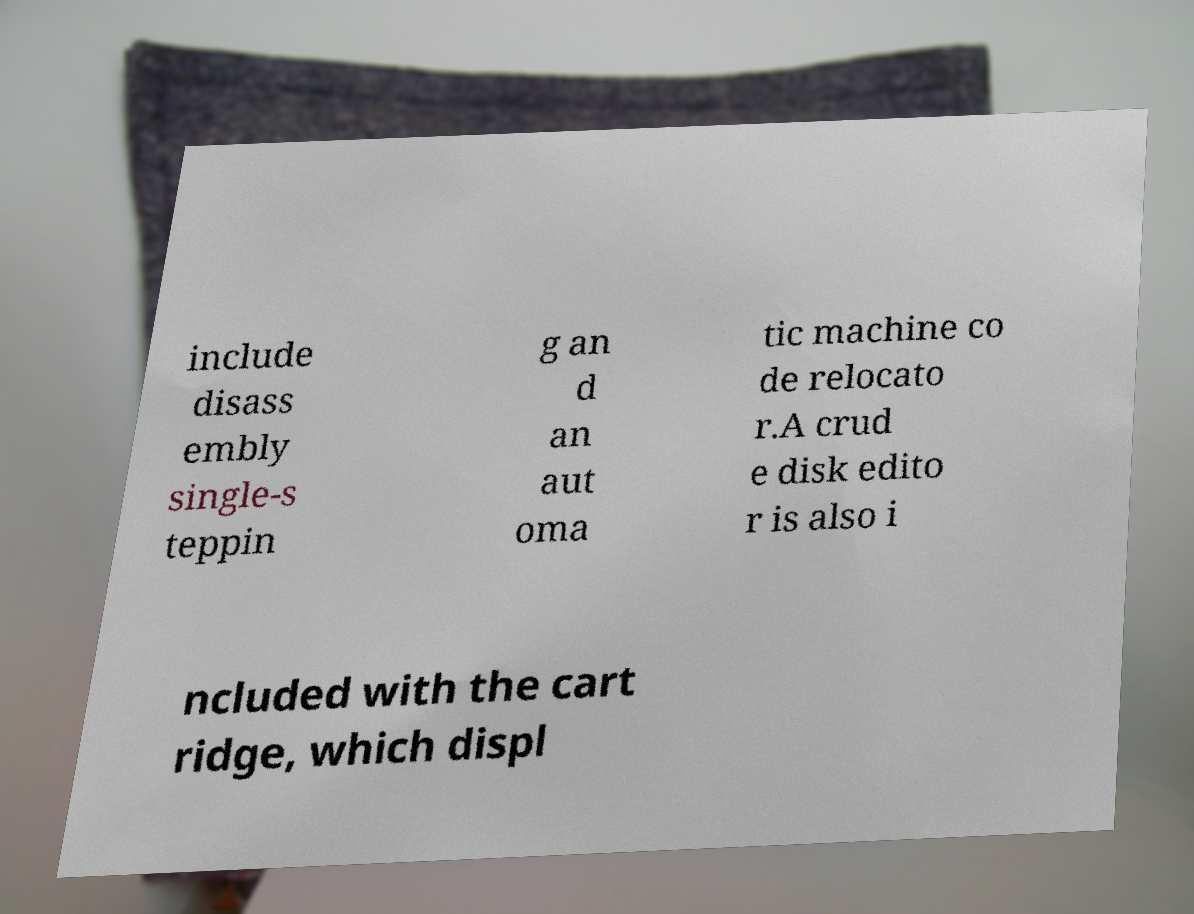For documentation purposes, I need the text within this image transcribed. Could you provide that? include disass embly single-s teppin g an d an aut oma tic machine co de relocato r.A crud e disk edito r is also i ncluded with the cart ridge, which displ 